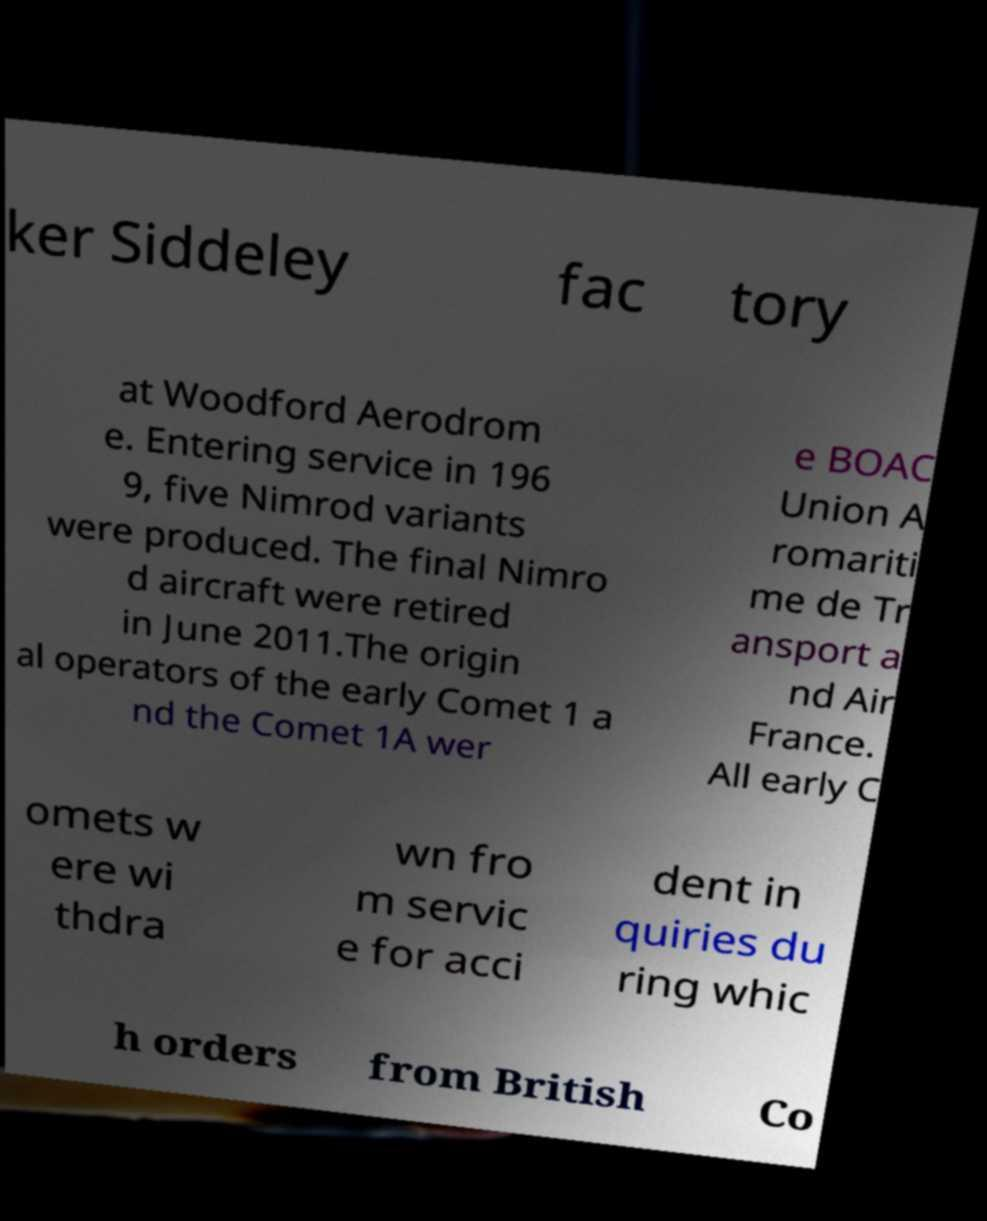Could you extract and type out the text from this image? ker Siddeley fac tory at Woodford Aerodrom e. Entering service in 196 9, five Nimrod variants were produced. The final Nimro d aircraft were retired in June 2011.The origin al operators of the early Comet 1 a nd the Comet 1A wer e BOAC Union A romariti me de Tr ansport a nd Air France. All early C omets w ere wi thdra wn fro m servic e for acci dent in quiries du ring whic h orders from British Co 